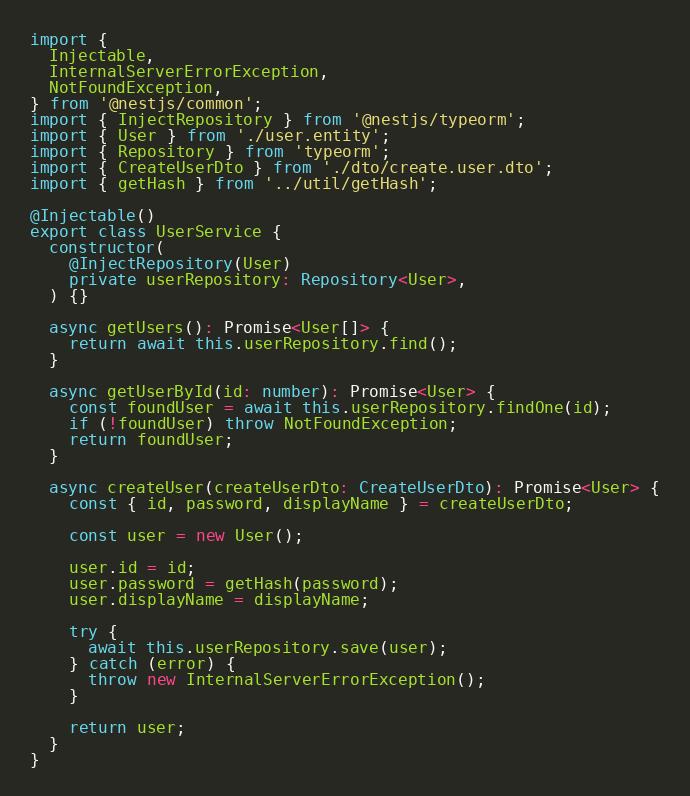Convert code to text. <code><loc_0><loc_0><loc_500><loc_500><_TypeScript_>import {
  Injectable,
  InternalServerErrorException,
  NotFoundException,
} from '@nestjs/common';
import { InjectRepository } from '@nestjs/typeorm';
import { User } from './user.entity';
import { Repository } from 'typeorm';
import { CreateUserDto } from './dto/create.user.dto';
import { getHash } from '../util/getHash';

@Injectable()
export class UserService {
  constructor(
    @InjectRepository(User)
    private userRepository: Repository<User>,
  ) {}

  async getUsers(): Promise<User[]> {
    return await this.userRepository.find();
  }

  async getUserById(id: number): Promise<User> {
    const foundUser = await this.userRepository.findOne(id);
    if (!foundUser) throw NotFoundException;
    return foundUser;
  }

  async createUser(createUserDto: CreateUserDto): Promise<User> {
    const { id, password, displayName } = createUserDto;

    const user = new User();

    user.id = id;
    user.password = getHash(password);
    user.displayName = displayName;

    try {
      await this.userRepository.save(user);
    } catch (error) {
      throw new InternalServerErrorException();
    }

    return user;
  }
}
</code> 